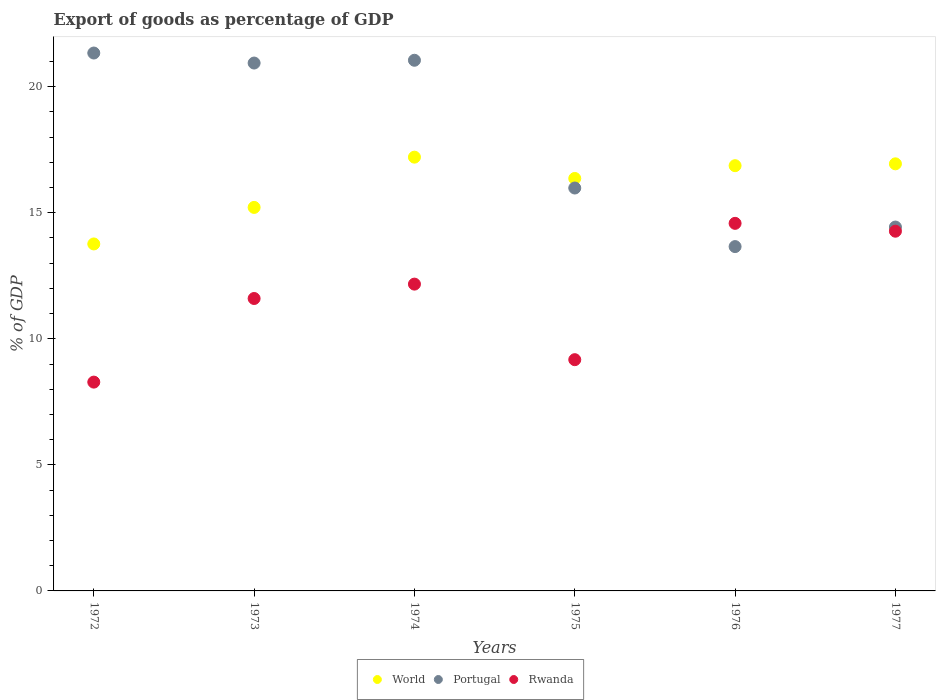How many different coloured dotlines are there?
Your response must be concise. 3. Is the number of dotlines equal to the number of legend labels?
Provide a short and direct response. Yes. What is the export of goods as percentage of GDP in World in 1972?
Your response must be concise. 13.76. Across all years, what is the maximum export of goods as percentage of GDP in World?
Give a very brief answer. 17.2. Across all years, what is the minimum export of goods as percentage of GDP in Portugal?
Provide a succinct answer. 13.66. In which year was the export of goods as percentage of GDP in Portugal maximum?
Your answer should be compact. 1972. In which year was the export of goods as percentage of GDP in World minimum?
Offer a very short reply. 1972. What is the total export of goods as percentage of GDP in Portugal in the graph?
Make the answer very short. 107.39. What is the difference between the export of goods as percentage of GDP in Portugal in 1975 and that in 1977?
Your answer should be very brief. 1.55. What is the difference between the export of goods as percentage of GDP in Rwanda in 1973 and the export of goods as percentage of GDP in Portugal in 1977?
Your answer should be compact. -2.83. What is the average export of goods as percentage of GDP in Rwanda per year?
Ensure brevity in your answer.  11.68. In the year 1972, what is the difference between the export of goods as percentage of GDP in Portugal and export of goods as percentage of GDP in Rwanda?
Provide a succinct answer. 13.05. What is the ratio of the export of goods as percentage of GDP in Portugal in 1973 to that in 1976?
Your answer should be compact. 1.53. Is the difference between the export of goods as percentage of GDP in Portugal in 1974 and 1976 greater than the difference between the export of goods as percentage of GDP in Rwanda in 1974 and 1976?
Make the answer very short. Yes. What is the difference between the highest and the second highest export of goods as percentage of GDP in Portugal?
Give a very brief answer. 0.29. What is the difference between the highest and the lowest export of goods as percentage of GDP in Portugal?
Offer a terse response. 7.68. Is the sum of the export of goods as percentage of GDP in Portugal in 1972 and 1976 greater than the maximum export of goods as percentage of GDP in World across all years?
Ensure brevity in your answer.  Yes. Does the export of goods as percentage of GDP in Rwanda monotonically increase over the years?
Your answer should be very brief. No. Is the export of goods as percentage of GDP in Portugal strictly greater than the export of goods as percentage of GDP in World over the years?
Ensure brevity in your answer.  No. How many legend labels are there?
Your response must be concise. 3. What is the title of the graph?
Give a very brief answer. Export of goods as percentage of GDP. What is the label or title of the Y-axis?
Provide a succinct answer. % of GDP. What is the % of GDP in World in 1972?
Ensure brevity in your answer.  13.76. What is the % of GDP of Portugal in 1972?
Your answer should be compact. 21.33. What is the % of GDP of Rwanda in 1972?
Give a very brief answer. 8.28. What is the % of GDP of World in 1973?
Your answer should be very brief. 15.21. What is the % of GDP in Portugal in 1973?
Your answer should be very brief. 20.94. What is the % of GDP in Rwanda in 1973?
Give a very brief answer. 11.6. What is the % of GDP in World in 1974?
Ensure brevity in your answer.  17.2. What is the % of GDP in Portugal in 1974?
Keep it short and to the point. 21.05. What is the % of GDP of Rwanda in 1974?
Provide a succinct answer. 12.17. What is the % of GDP of World in 1975?
Make the answer very short. 16.36. What is the % of GDP of Portugal in 1975?
Make the answer very short. 15.98. What is the % of GDP in Rwanda in 1975?
Offer a very short reply. 9.17. What is the % of GDP in World in 1976?
Give a very brief answer. 16.87. What is the % of GDP in Portugal in 1976?
Provide a short and direct response. 13.66. What is the % of GDP of Rwanda in 1976?
Your answer should be very brief. 14.58. What is the % of GDP of World in 1977?
Offer a very short reply. 16.94. What is the % of GDP in Portugal in 1977?
Provide a short and direct response. 14.43. What is the % of GDP in Rwanda in 1977?
Offer a very short reply. 14.27. Across all years, what is the maximum % of GDP of World?
Your answer should be compact. 17.2. Across all years, what is the maximum % of GDP in Portugal?
Your response must be concise. 21.33. Across all years, what is the maximum % of GDP in Rwanda?
Provide a short and direct response. 14.58. Across all years, what is the minimum % of GDP of World?
Keep it short and to the point. 13.76. Across all years, what is the minimum % of GDP of Portugal?
Make the answer very short. 13.66. Across all years, what is the minimum % of GDP of Rwanda?
Provide a short and direct response. 8.28. What is the total % of GDP of World in the graph?
Make the answer very short. 96.34. What is the total % of GDP in Portugal in the graph?
Your response must be concise. 107.39. What is the total % of GDP of Rwanda in the graph?
Make the answer very short. 70.07. What is the difference between the % of GDP in World in 1972 and that in 1973?
Make the answer very short. -1.45. What is the difference between the % of GDP of Portugal in 1972 and that in 1973?
Offer a terse response. 0.4. What is the difference between the % of GDP in Rwanda in 1972 and that in 1973?
Offer a very short reply. -3.32. What is the difference between the % of GDP of World in 1972 and that in 1974?
Provide a succinct answer. -3.44. What is the difference between the % of GDP in Portugal in 1972 and that in 1974?
Your answer should be compact. 0.29. What is the difference between the % of GDP of Rwanda in 1972 and that in 1974?
Your response must be concise. -3.89. What is the difference between the % of GDP in World in 1972 and that in 1975?
Give a very brief answer. -2.6. What is the difference between the % of GDP in Portugal in 1972 and that in 1975?
Offer a very short reply. 5.35. What is the difference between the % of GDP in Rwanda in 1972 and that in 1975?
Make the answer very short. -0.89. What is the difference between the % of GDP in World in 1972 and that in 1976?
Offer a terse response. -3.1. What is the difference between the % of GDP in Portugal in 1972 and that in 1976?
Provide a succinct answer. 7.68. What is the difference between the % of GDP of Rwanda in 1972 and that in 1976?
Offer a terse response. -6.3. What is the difference between the % of GDP in World in 1972 and that in 1977?
Provide a short and direct response. -3.18. What is the difference between the % of GDP of Portugal in 1972 and that in 1977?
Ensure brevity in your answer.  6.9. What is the difference between the % of GDP in Rwanda in 1972 and that in 1977?
Your answer should be very brief. -5.99. What is the difference between the % of GDP in World in 1973 and that in 1974?
Your answer should be compact. -1.99. What is the difference between the % of GDP in Portugal in 1973 and that in 1974?
Offer a terse response. -0.11. What is the difference between the % of GDP in Rwanda in 1973 and that in 1974?
Ensure brevity in your answer.  -0.57. What is the difference between the % of GDP of World in 1973 and that in 1975?
Provide a succinct answer. -1.15. What is the difference between the % of GDP of Portugal in 1973 and that in 1975?
Provide a succinct answer. 4.96. What is the difference between the % of GDP in Rwanda in 1973 and that in 1975?
Offer a terse response. 2.43. What is the difference between the % of GDP in World in 1973 and that in 1976?
Your answer should be very brief. -1.66. What is the difference between the % of GDP in Portugal in 1973 and that in 1976?
Offer a very short reply. 7.28. What is the difference between the % of GDP in Rwanda in 1973 and that in 1976?
Give a very brief answer. -2.98. What is the difference between the % of GDP in World in 1973 and that in 1977?
Make the answer very short. -1.73. What is the difference between the % of GDP of Portugal in 1973 and that in 1977?
Give a very brief answer. 6.5. What is the difference between the % of GDP in Rwanda in 1973 and that in 1977?
Offer a terse response. -2.67. What is the difference between the % of GDP in World in 1974 and that in 1975?
Give a very brief answer. 0.84. What is the difference between the % of GDP of Portugal in 1974 and that in 1975?
Provide a succinct answer. 5.07. What is the difference between the % of GDP of Rwanda in 1974 and that in 1975?
Offer a terse response. 3. What is the difference between the % of GDP of World in 1974 and that in 1976?
Ensure brevity in your answer.  0.34. What is the difference between the % of GDP in Portugal in 1974 and that in 1976?
Ensure brevity in your answer.  7.39. What is the difference between the % of GDP of Rwanda in 1974 and that in 1976?
Offer a terse response. -2.41. What is the difference between the % of GDP of World in 1974 and that in 1977?
Make the answer very short. 0.26. What is the difference between the % of GDP of Portugal in 1974 and that in 1977?
Offer a very short reply. 6.62. What is the difference between the % of GDP of Rwanda in 1974 and that in 1977?
Make the answer very short. -2.1. What is the difference between the % of GDP in World in 1975 and that in 1976?
Provide a short and direct response. -0.51. What is the difference between the % of GDP in Portugal in 1975 and that in 1976?
Keep it short and to the point. 2.32. What is the difference between the % of GDP in Rwanda in 1975 and that in 1976?
Ensure brevity in your answer.  -5.41. What is the difference between the % of GDP in World in 1975 and that in 1977?
Offer a very short reply. -0.58. What is the difference between the % of GDP of Portugal in 1975 and that in 1977?
Your answer should be compact. 1.55. What is the difference between the % of GDP in Rwanda in 1975 and that in 1977?
Give a very brief answer. -5.1. What is the difference between the % of GDP of World in 1976 and that in 1977?
Your answer should be compact. -0.07. What is the difference between the % of GDP in Portugal in 1976 and that in 1977?
Keep it short and to the point. -0.78. What is the difference between the % of GDP of Rwanda in 1976 and that in 1977?
Ensure brevity in your answer.  0.31. What is the difference between the % of GDP in World in 1972 and the % of GDP in Portugal in 1973?
Your response must be concise. -7.17. What is the difference between the % of GDP of World in 1972 and the % of GDP of Rwanda in 1973?
Your response must be concise. 2.16. What is the difference between the % of GDP of Portugal in 1972 and the % of GDP of Rwanda in 1973?
Provide a short and direct response. 9.74. What is the difference between the % of GDP in World in 1972 and the % of GDP in Portugal in 1974?
Give a very brief answer. -7.29. What is the difference between the % of GDP of World in 1972 and the % of GDP of Rwanda in 1974?
Make the answer very short. 1.59. What is the difference between the % of GDP in Portugal in 1972 and the % of GDP in Rwanda in 1974?
Provide a succinct answer. 9.17. What is the difference between the % of GDP of World in 1972 and the % of GDP of Portugal in 1975?
Your response must be concise. -2.22. What is the difference between the % of GDP in World in 1972 and the % of GDP in Rwanda in 1975?
Keep it short and to the point. 4.59. What is the difference between the % of GDP in Portugal in 1972 and the % of GDP in Rwanda in 1975?
Make the answer very short. 12.16. What is the difference between the % of GDP of World in 1972 and the % of GDP of Portugal in 1976?
Offer a terse response. 0.1. What is the difference between the % of GDP of World in 1972 and the % of GDP of Rwanda in 1976?
Offer a terse response. -0.82. What is the difference between the % of GDP in Portugal in 1972 and the % of GDP in Rwanda in 1976?
Keep it short and to the point. 6.76. What is the difference between the % of GDP in World in 1972 and the % of GDP in Portugal in 1977?
Offer a very short reply. -0.67. What is the difference between the % of GDP of World in 1972 and the % of GDP of Rwanda in 1977?
Provide a short and direct response. -0.51. What is the difference between the % of GDP in Portugal in 1972 and the % of GDP in Rwanda in 1977?
Give a very brief answer. 7.07. What is the difference between the % of GDP of World in 1973 and the % of GDP of Portugal in 1974?
Offer a very short reply. -5.84. What is the difference between the % of GDP in World in 1973 and the % of GDP in Rwanda in 1974?
Offer a terse response. 3.04. What is the difference between the % of GDP in Portugal in 1973 and the % of GDP in Rwanda in 1974?
Your answer should be very brief. 8.77. What is the difference between the % of GDP of World in 1973 and the % of GDP of Portugal in 1975?
Ensure brevity in your answer.  -0.77. What is the difference between the % of GDP in World in 1973 and the % of GDP in Rwanda in 1975?
Offer a very short reply. 6.04. What is the difference between the % of GDP in Portugal in 1973 and the % of GDP in Rwanda in 1975?
Provide a short and direct response. 11.77. What is the difference between the % of GDP in World in 1973 and the % of GDP in Portugal in 1976?
Provide a succinct answer. 1.55. What is the difference between the % of GDP of World in 1973 and the % of GDP of Rwanda in 1976?
Keep it short and to the point. 0.63. What is the difference between the % of GDP of Portugal in 1973 and the % of GDP of Rwanda in 1976?
Provide a succinct answer. 6.36. What is the difference between the % of GDP of World in 1973 and the % of GDP of Portugal in 1977?
Ensure brevity in your answer.  0.78. What is the difference between the % of GDP in World in 1973 and the % of GDP in Rwanda in 1977?
Offer a very short reply. 0.94. What is the difference between the % of GDP in Portugal in 1973 and the % of GDP in Rwanda in 1977?
Offer a terse response. 6.67. What is the difference between the % of GDP in World in 1974 and the % of GDP in Portugal in 1975?
Offer a terse response. 1.22. What is the difference between the % of GDP in World in 1974 and the % of GDP in Rwanda in 1975?
Your answer should be very brief. 8.03. What is the difference between the % of GDP in Portugal in 1974 and the % of GDP in Rwanda in 1975?
Offer a very short reply. 11.88. What is the difference between the % of GDP of World in 1974 and the % of GDP of Portugal in 1976?
Give a very brief answer. 3.55. What is the difference between the % of GDP of World in 1974 and the % of GDP of Rwanda in 1976?
Give a very brief answer. 2.63. What is the difference between the % of GDP of Portugal in 1974 and the % of GDP of Rwanda in 1976?
Your answer should be very brief. 6.47. What is the difference between the % of GDP of World in 1974 and the % of GDP of Portugal in 1977?
Ensure brevity in your answer.  2.77. What is the difference between the % of GDP in World in 1974 and the % of GDP in Rwanda in 1977?
Provide a succinct answer. 2.94. What is the difference between the % of GDP of Portugal in 1974 and the % of GDP of Rwanda in 1977?
Ensure brevity in your answer.  6.78. What is the difference between the % of GDP in World in 1975 and the % of GDP in Portugal in 1976?
Your response must be concise. 2.7. What is the difference between the % of GDP in World in 1975 and the % of GDP in Rwanda in 1976?
Provide a succinct answer. 1.78. What is the difference between the % of GDP of Portugal in 1975 and the % of GDP of Rwanda in 1976?
Give a very brief answer. 1.4. What is the difference between the % of GDP of World in 1975 and the % of GDP of Portugal in 1977?
Your answer should be very brief. 1.93. What is the difference between the % of GDP of World in 1975 and the % of GDP of Rwanda in 1977?
Give a very brief answer. 2.09. What is the difference between the % of GDP in Portugal in 1975 and the % of GDP in Rwanda in 1977?
Provide a succinct answer. 1.71. What is the difference between the % of GDP in World in 1976 and the % of GDP in Portugal in 1977?
Your answer should be compact. 2.43. What is the difference between the % of GDP in World in 1976 and the % of GDP in Rwanda in 1977?
Keep it short and to the point. 2.6. What is the difference between the % of GDP in Portugal in 1976 and the % of GDP in Rwanda in 1977?
Offer a very short reply. -0.61. What is the average % of GDP of World per year?
Ensure brevity in your answer.  16.06. What is the average % of GDP in Portugal per year?
Make the answer very short. 17.9. What is the average % of GDP in Rwanda per year?
Offer a very short reply. 11.68. In the year 1972, what is the difference between the % of GDP of World and % of GDP of Portugal?
Your answer should be very brief. -7.57. In the year 1972, what is the difference between the % of GDP of World and % of GDP of Rwanda?
Your answer should be compact. 5.48. In the year 1972, what is the difference between the % of GDP in Portugal and % of GDP in Rwanda?
Your response must be concise. 13.05. In the year 1973, what is the difference between the % of GDP in World and % of GDP in Portugal?
Provide a succinct answer. -5.73. In the year 1973, what is the difference between the % of GDP in World and % of GDP in Rwanda?
Offer a very short reply. 3.61. In the year 1973, what is the difference between the % of GDP of Portugal and % of GDP of Rwanda?
Offer a terse response. 9.34. In the year 1974, what is the difference between the % of GDP in World and % of GDP in Portugal?
Provide a short and direct response. -3.84. In the year 1974, what is the difference between the % of GDP of World and % of GDP of Rwanda?
Keep it short and to the point. 5.04. In the year 1974, what is the difference between the % of GDP of Portugal and % of GDP of Rwanda?
Provide a short and direct response. 8.88. In the year 1975, what is the difference between the % of GDP in World and % of GDP in Portugal?
Your answer should be very brief. 0.38. In the year 1975, what is the difference between the % of GDP of World and % of GDP of Rwanda?
Offer a very short reply. 7.19. In the year 1975, what is the difference between the % of GDP of Portugal and % of GDP of Rwanda?
Make the answer very short. 6.81. In the year 1976, what is the difference between the % of GDP of World and % of GDP of Portugal?
Provide a succinct answer. 3.21. In the year 1976, what is the difference between the % of GDP in World and % of GDP in Rwanda?
Offer a terse response. 2.29. In the year 1976, what is the difference between the % of GDP of Portugal and % of GDP of Rwanda?
Offer a very short reply. -0.92. In the year 1977, what is the difference between the % of GDP in World and % of GDP in Portugal?
Your response must be concise. 2.51. In the year 1977, what is the difference between the % of GDP of World and % of GDP of Rwanda?
Your response must be concise. 2.67. In the year 1977, what is the difference between the % of GDP of Portugal and % of GDP of Rwanda?
Your response must be concise. 0.16. What is the ratio of the % of GDP of World in 1972 to that in 1973?
Give a very brief answer. 0.9. What is the ratio of the % of GDP in Rwanda in 1972 to that in 1973?
Give a very brief answer. 0.71. What is the ratio of the % of GDP in World in 1972 to that in 1974?
Give a very brief answer. 0.8. What is the ratio of the % of GDP in Portugal in 1972 to that in 1974?
Make the answer very short. 1.01. What is the ratio of the % of GDP of Rwanda in 1972 to that in 1974?
Offer a very short reply. 0.68. What is the ratio of the % of GDP in World in 1972 to that in 1975?
Offer a very short reply. 0.84. What is the ratio of the % of GDP in Portugal in 1972 to that in 1975?
Your response must be concise. 1.33. What is the ratio of the % of GDP of Rwanda in 1972 to that in 1975?
Your answer should be compact. 0.9. What is the ratio of the % of GDP in World in 1972 to that in 1976?
Provide a succinct answer. 0.82. What is the ratio of the % of GDP in Portugal in 1972 to that in 1976?
Keep it short and to the point. 1.56. What is the ratio of the % of GDP in Rwanda in 1972 to that in 1976?
Offer a very short reply. 0.57. What is the ratio of the % of GDP in World in 1972 to that in 1977?
Make the answer very short. 0.81. What is the ratio of the % of GDP in Portugal in 1972 to that in 1977?
Give a very brief answer. 1.48. What is the ratio of the % of GDP of Rwanda in 1972 to that in 1977?
Provide a succinct answer. 0.58. What is the ratio of the % of GDP of World in 1973 to that in 1974?
Your answer should be compact. 0.88. What is the ratio of the % of GDP in Portugal in 1973 to that in 1974?
Your response must be concise. 0.99. What is the ratio of the % of GDP in Rwanda in 1973 to that in 1974?
Give a very brief answer. 0.95. What is the ratio of the % of GDP in World in 1973 to that in 1975?
Ensure brevity in your answer.  0.93. What is the ratio of the % of GDP of Portugal in 1973 to that in 1975?
Your answer should be compact. 1.31. What is the ratio of the % of GDP of Rwanda in 1973 to that in 1975?
Ensure brevity in your answer.  1.26. What is the ratio of the % of GDP of World in 1973 to that in 1976?
Provide a succinct answer. 0.9. What is the ratio of the % of GDP of Portugal in 1973 to that in 1976?
Provide a short and direct response. 1.53. What is the ratio of the % of GDP of Rwanda in 1973 to that in 1976?
Provide a short and direct response. 0.8. What is the ratio of the % of GDP of World in 1973 to that in 1977?
Ensure brevity in your answer.  0.9. What is the ratio of the % of GDP of Portugal in 1973 to that in 1977?
Offer a terse response. 1.45. What is the ratio of the % of GDP of Rwanda in 1973 to that in 1977?
Ensure brevity in your answer.  0.81. What is the ratio of the % of GDP of World in 1974 to that in 1975?
Ensure brevity in your answer.  1.05. What is the ratio of the % of GDP of Portugal in 1974 to that in 1975?
Ensure brevity in your answer.  1.32. What is the ratio of the % of GDP in Rwanda in 1974 to that in 1975?
Your response must be concise. 1.33. What is the ratio of the % of GDP of World in 1974 to that in 1976?
Provide a succinct answer. 1.02. What is the ratio of the % of GDP in Portugal in 1974 to that in 1976?
Make the answer very short. 1.54. What is the ratio of the % of GDP in Rwanda in 1974 to that in 1976?
Make the answer very short. 0.83. What is the ratio of the % of GDP of World in 1974 to that in 1977?
Your response must be concise. 1.02. What is the ratio of the % of GDP in Portugal in 1974 to that in 1977?
Provide a short and direct response. 1.46. What is the ratio of the % of GDP in Rwanda in 1974 to that in 1977?
Your response must be concise. 0.85. What is the ratio of the % of GDP of Portugal in 1975 to that in 1976?
Provide a short and direct response. 1.17. What is the ratio of the % of GDP in Rwanda in 1975 to that in 1976?
Provide a succinct answer. 0.63. What is the ratio of the % of GDP of World in 1975 to that in 1977?
Offer a very short reply. 0.97. What is the ratio of the % of GDP of Portugal in 1975 to that in 1977?
Provide a short and direct response. 1.11. What is the ratio of the % of GDP in Rwanda in 1975 to that in 1977?
Make the answer very short. 0.64. What is the ratio of the % of GDP of World in 1976 to that in 1977?
Provide a short and direct response. 1. What is the ratio of the % of GDP of Portugal in 1976 to that in 1977?
Give a very brief answer. 0.95. What is the ratio of the % of GDP of Rwanda in 1976 to that in 1977?
Your answer should be compact. 1.02. What is the difference between the highest and the second highest % of GDP in World?
Ensure brevity in your answer.  0.26. What is the difference between the highest and the second highest % of GDP in Portugal?
Keep it short and to the point. 0.29. What is the difference between the highest and the second highest % of GDP in Rwanda?
Make the answer very short. 0.31. What is the difference between the highest and the lowest % of GDP of World?
Make the answer very short. 3.44. What is the difference between the highest and the lowest % of GDP in Portugal?
Offer a very short reply. 7.68. What is the difference between the highest and the lowest % of GDP of Rwanda?
Your answer should be compact. 6.3. 